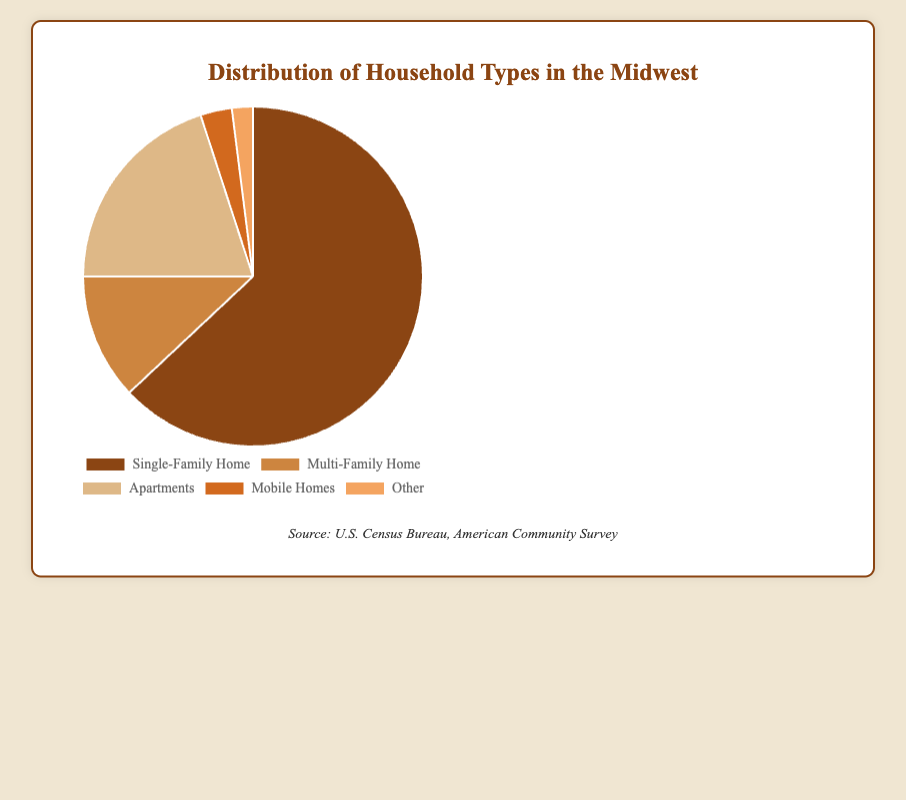What is the most common type of household in the Midwest? By observing the pie chart, the largest section is for Single-Family Home, which has a percentage value of 63%. This makes it the most common type of household.
Answer: Single-Family Home Which household type represents the smallest segment in the chart? The pie chart shows that "Other" has the smallest segment with a percentage of 2%.
Answer: Other What is the combined percentage of Multi-Family Homes and Apartments? To find the combined percentage, we sum the percentages of Multi-Family Homes (12%) and Apartments (20%). So, 12% + 20% = 32%.
Answer: 32% Are there more Apartments or Single-Family Homes in the Midwest? By looking at the chart, Single-Family Homes constitute 63% whereas Apartments constitute 20%. Thus, there are more Single-Family Homes.
Answer: Single-Family Homes What is the difference in percentage between Mobile Homes and Other household types? To find this difference, subtract the percentage of Other (2%) from Mobile Homes (3%). So, 3% - 2% = 1%.
Answer: 1% How does the percentage of Single-Family Homes compare to the combined percentage of Mobile Homes and Other? First, calculate the combined percentage of Mobile Homes and Other, which is 3% + 2% = 5%. Then, compare it to the percentage of Single-Family Homes, which is 63%. 63% is much higher than 5%.
Answer: Single-Family Homes Which color represents Multi-Family Homes on the chart? The pie chart typically uses a legend to match household types with colors. Multi-Family Homes are represented by the color '#cd853f', which is a shade of brown.
Answer: Brown 